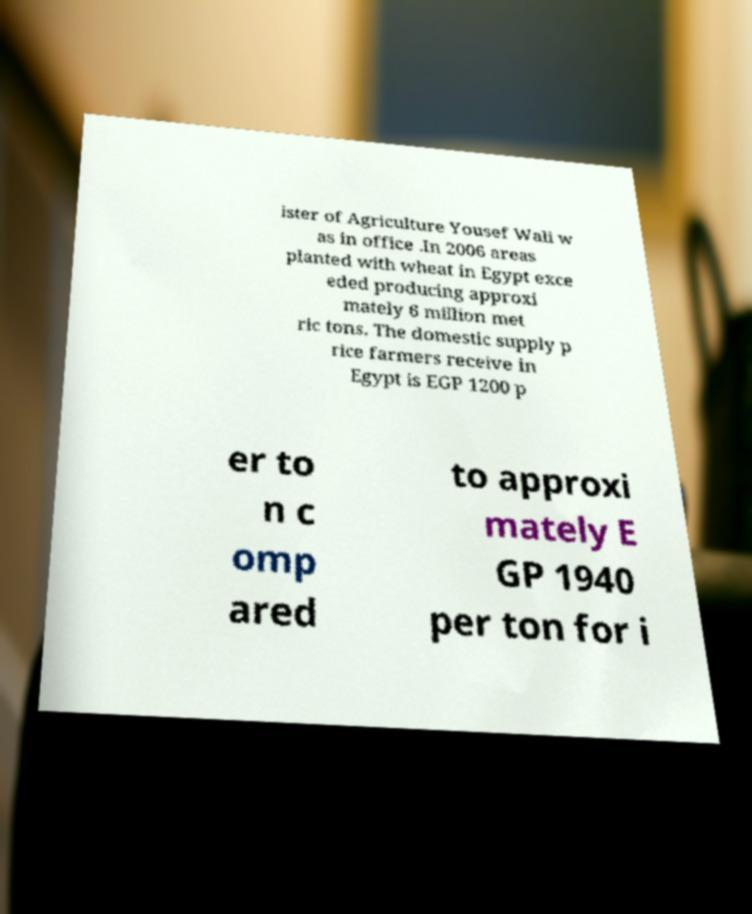Please read and relay the text visible in this image. What does it say? ister of Agriculture Yousef Wali w as in office .In 2006 areas planted with wheat in Egypt exce eded producing approxi mately 6 million met ric tons. The domestic supply p rice farmers receive in Egypt is EGP 1200 p er to n c omp ared to approxi mately E GP 1940 per ton for i 